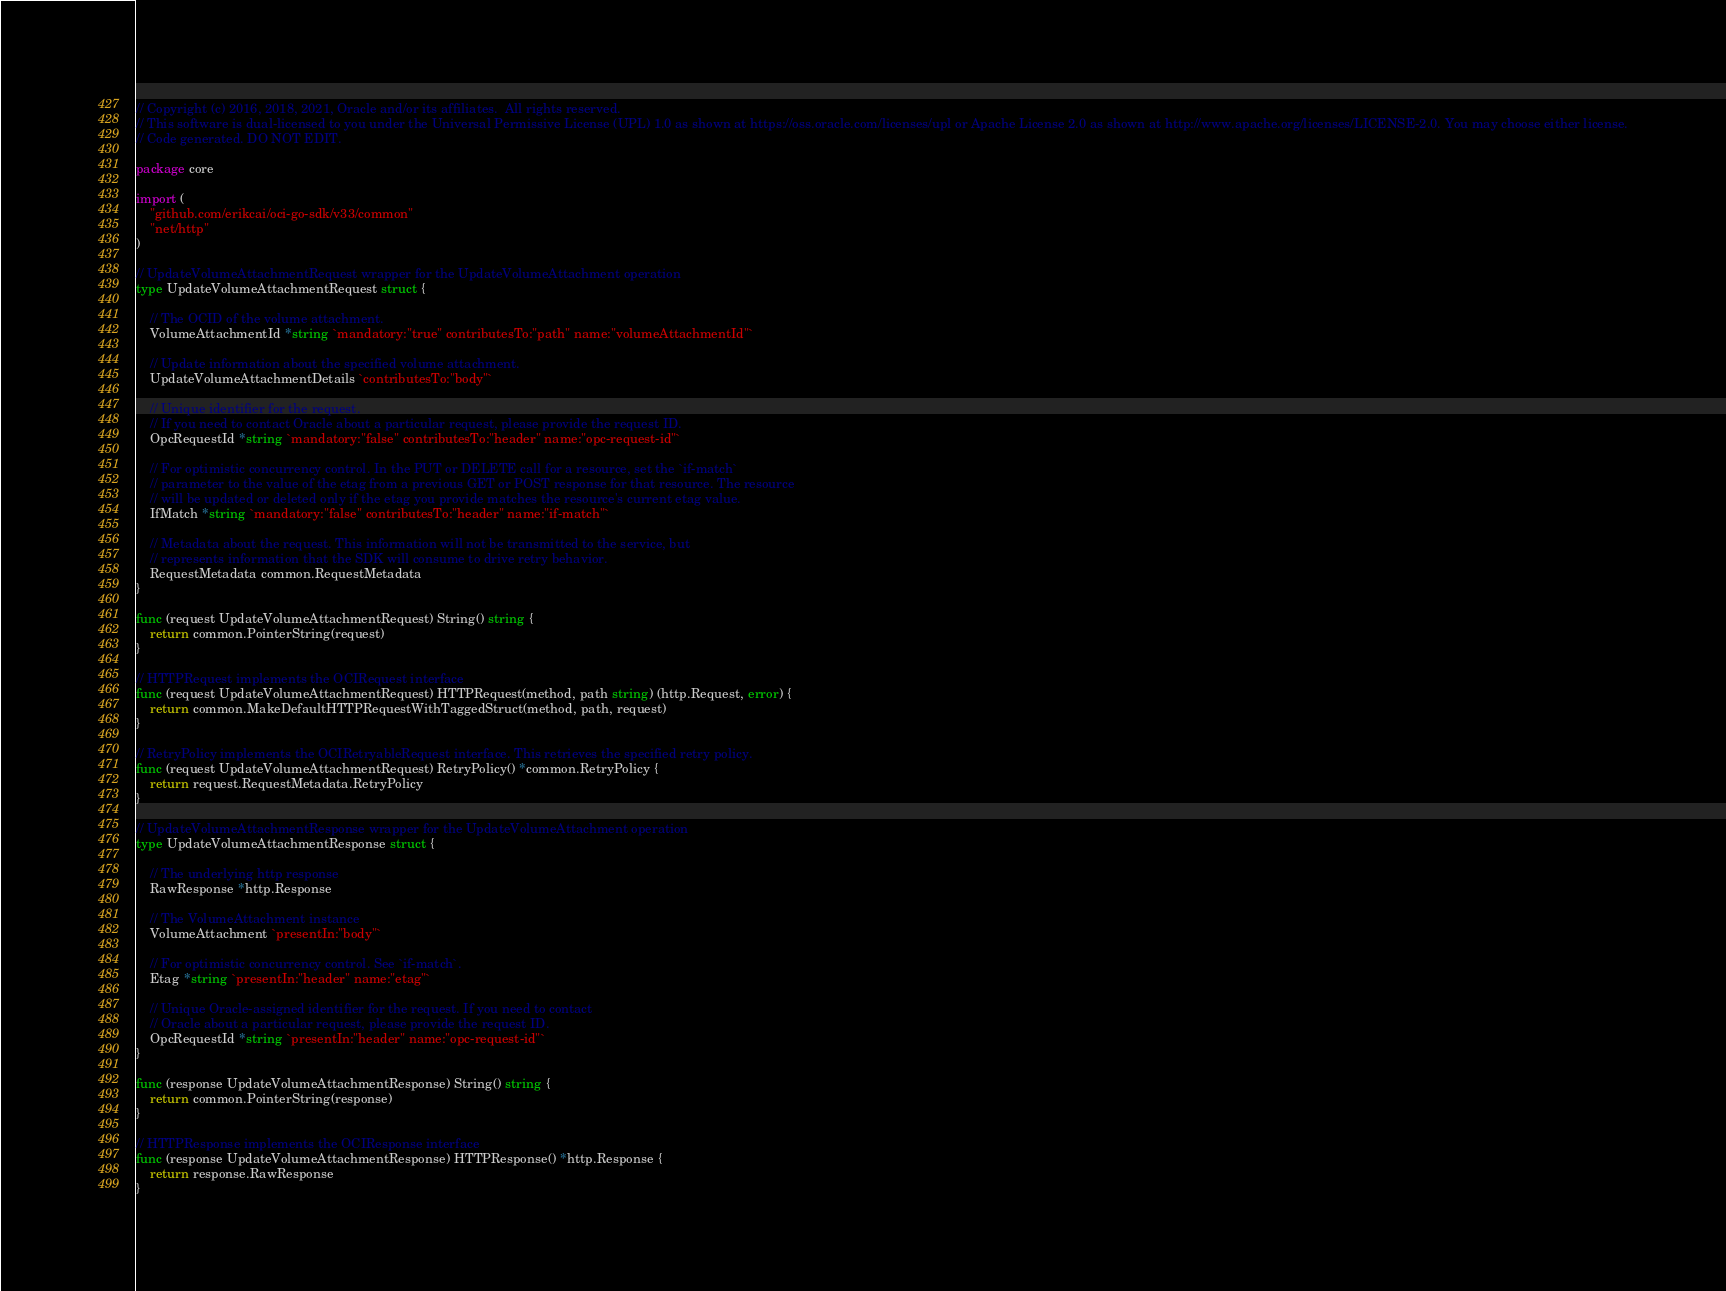<code> <loc_0><loc_0><loc_500><loc_500><_Go_>// Copyright (c) 2016, 2018, 2021, Oracle and/or its affiliates.  All rights reserved.
// This software is dual-licensed to you under the Universal Permissive License (UPL) 1.0 as shown at https://oss.oracle.com/licenses/upl or Apache License 2.0 as shown at http://www.apache.org/licenses/LICENSE-2.0. You may choose either license.
// Code generated. DO NOT EDIT.

package core

import (
	"github.com/erikcai/oci-go-sdk/v33/common"
	"net/http"
)

// UpdateVolumeAttachmentRequest wrapper for the UpdateVolumeAttachment operation
type UpdateVolumeAttachmentRequest struct {

	// The OCID of the volume attachment.
	VolumeAttachmentId *string `mandatory:"true" contributesTo:"path" name:"volumeAttachmentId"`

	// Update information about the specified volume attachment.
	UpdateVolumeAttachmentDetails `contributesTo:"body"`

	// Unique identifier for the request.
	// If you need to contact Oracle about a particular request, please provide the request ID.
	OpcRequestId *string `mandatory:"false" contributesTo:"header" name:"opc-request-id"`

	// For optimistic concurrency control. In the PUT or DELETE call for a resource, set the `if-match`
	// parameter to the value of the etag from a previous GET or POST response for that resource. The resource
	// will be updated or deleted only if the etag you provide matches the resource's current etag value.
	IfMatch *string `mandatory:"false" contributesTo:"header" name:"if-match"`

	// Metadata about the request. This information will not be transmitted to the service, but
	// represents information that the SDK will consume to drive retry behavior.
	RequestMetadata common.RequestMetadata
}

func (request UpdateVolumeAttachmentRequest) String() string {
	return common.PointerString(request)
}

// HTTPRequest implements the OCIRequest interface
func (request UpdateVolumeAttachmentRequest) HTTPRequest(method, path string) (http.Request, error) {
	return common.MakeDefaultHTTPRequestWithTaggedStruct(method, path, request)
}

// RetryPolicy implements the OCIRetryableRequest interface. This retrieves the specified retry policy.
func (request UpdateVolumeAttachmentRequest) RetryPolicy() *common.RetryPolicy {
	return request.RequestMetadata.RetryPolicy
}

// UpdateVolumeAttachmentResponse wrapper for the UpdateVolumeAttachment operation
type UpdateVolumeAttachmentResponse struct {

	// The underlying http response
	RawResponse *http.Response

	// The VolumeAttachment instance
	VolumeAttachment `presentIn:"body"`

	// For optimistic concurrency control. See `if-match`.
	Etag *string `presentIn:"header" name:"etag"`

	// Unique Oracle-assigned identifier for the request. If you need to contact
	// Oracle about a particular request, please provide the request ID.
	OpcRequestId *string `presentIn:"header" name:"opc-request-id"`
}

func (response UpdateVolumeAttachmentResponse) String() string {
	return common.PointerString(response)
}

// HTTPResponse implements the OCIResponse interface
func (response UpdateVolumeAttachmentResponse) HTTPResponse() *http.Response {
	return response.RawResponse
}
</code> 